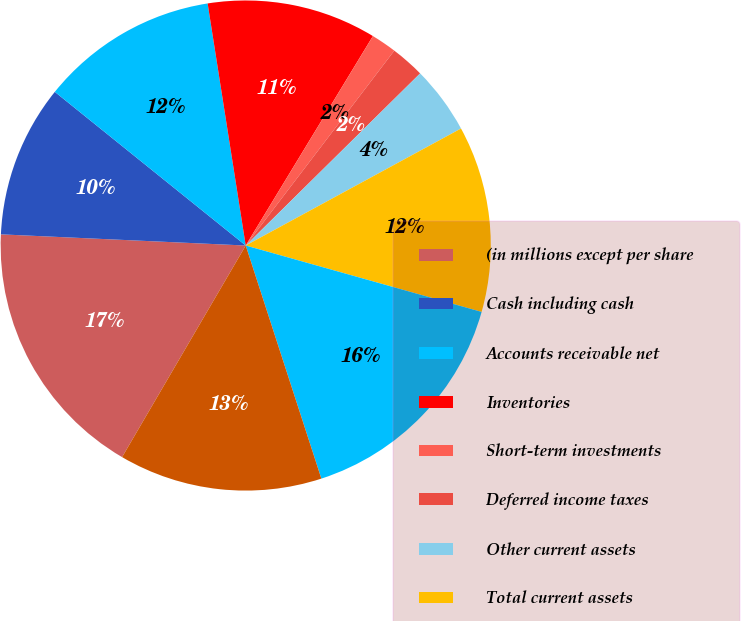Convert chart to OTSL. <chart><loc_0><loc_0><loc_500><loc_500><pie_chart><fcel>(in millions except per share<fcel>Cash including cash<fcel>Accounts receivable net<fcel>Inventories<fcel>Short-term investments<fcel>Deferred income taxes<fcel>Other current assets<fcel>Total current assets<fcel>Property plant and equipment<fcel>Less accumulated depreciation<nl><fcel>17.31%<fcel>10.06%<fcel>11.73%<fcel>11.17%<fcel>1.68%<fcel>2.24%<fcel>4.47%<fcel>12.29%<fcel>15.64%<fcel>13.41%<nl></chart> 